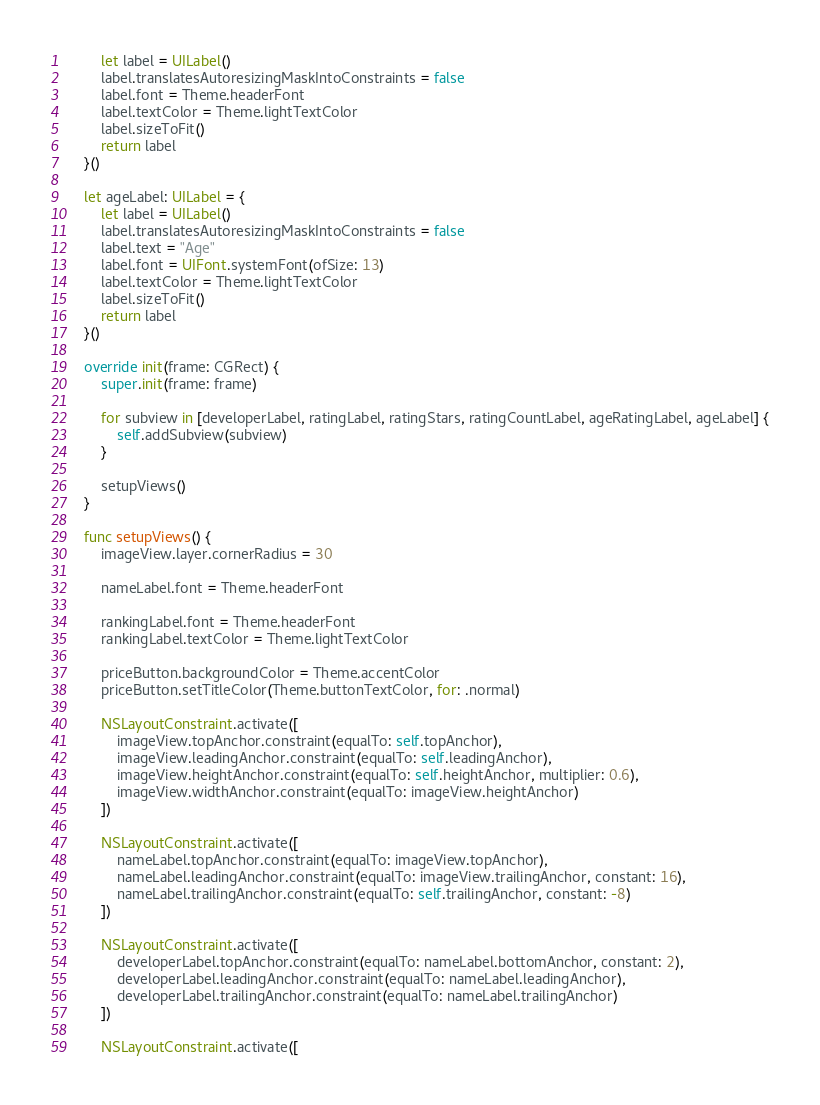<code> <loc_0><loc_0><loc_500><loc_500><_Swift_>        let label = UILabel()
        label.translatesAutoresizingMaskIntoConstraints = false
        label.font = Theme.headerFont
        label.textColor = Theme.lightTextColor
        label.sizeToFit()
        return label
    }()
    
    let ageLabel: UILabel = {
        let label = UILabel()
        label.translatesAutoresizingMaskIntoConstraints = false
        label.text = "Age"
        label.font = UIFont.systemFont(ofSize: 13)
        label.textColor = Theme.lightTextColor
        label.sizeToFit()
        return label
    }()

    override init(frame: CGRect) {
        super.init(frame: frame)
        
        for subview in [developerLabel, ratingLabel, ratingStars, ratingCountLabel, ageRatingLabel, ageLabel] {
            self.addSubview(subview)
        }
        
        setupViews()
    }
    
    func setupViews() {
        imageView.layer.cornerRadius = 30
        
        nameLabel.font = Theme.headerFont
        
        rankingLabel.font = Theme.headerFont
        rankingLabel.textColor = Theme.lightTextColor
        
        priceButton.backgroundColor = Theme.accentColor
        priceButton.setTitleColor(Theme.buttonTextColor, for: .normal)
        
        NSLayoutConstraint.activate([
            imageView.topAnchor.constraint(equalTo: self.topAnchor),
            imageView.leadingAnchor.constraint(equalTo: self.leadingAnchor),
            imageView.heightAnchor.constraint(equalTo: self.heightAnchor, multiplier: 0.6),
            imageView.widthAnchor.constraint(equalTo: imageView.heightAnchor)
        ])
        
        NSLayoutConstraint.activate([
            nameLabel.topAnchor.constraint(equalTo: imageView.topAnchor),
            nameLabel.leadingAnchor.constraint(equalTo: imageView.trailingAnchor, constant: 16),
            nameLabel.trailingAnchor.constraint(equalTo: self.trailingAnchor, constant: -8)
        ])
        
        NSLayoutConstraint.activate([
            developerLabel.topAnchor.constraint(equalTo: nameLabel.bottomAnchor, constant: 2),
            developerLabel.leadingAnchor.constraint(equalTo: nameLabel.leadingAnchor),
            developerLabel.trailingAnchor.constraint(equalTo: nameLabel.trailingAnchor)
        ])
        
        NSLayoutConstraint.activate([</code> 